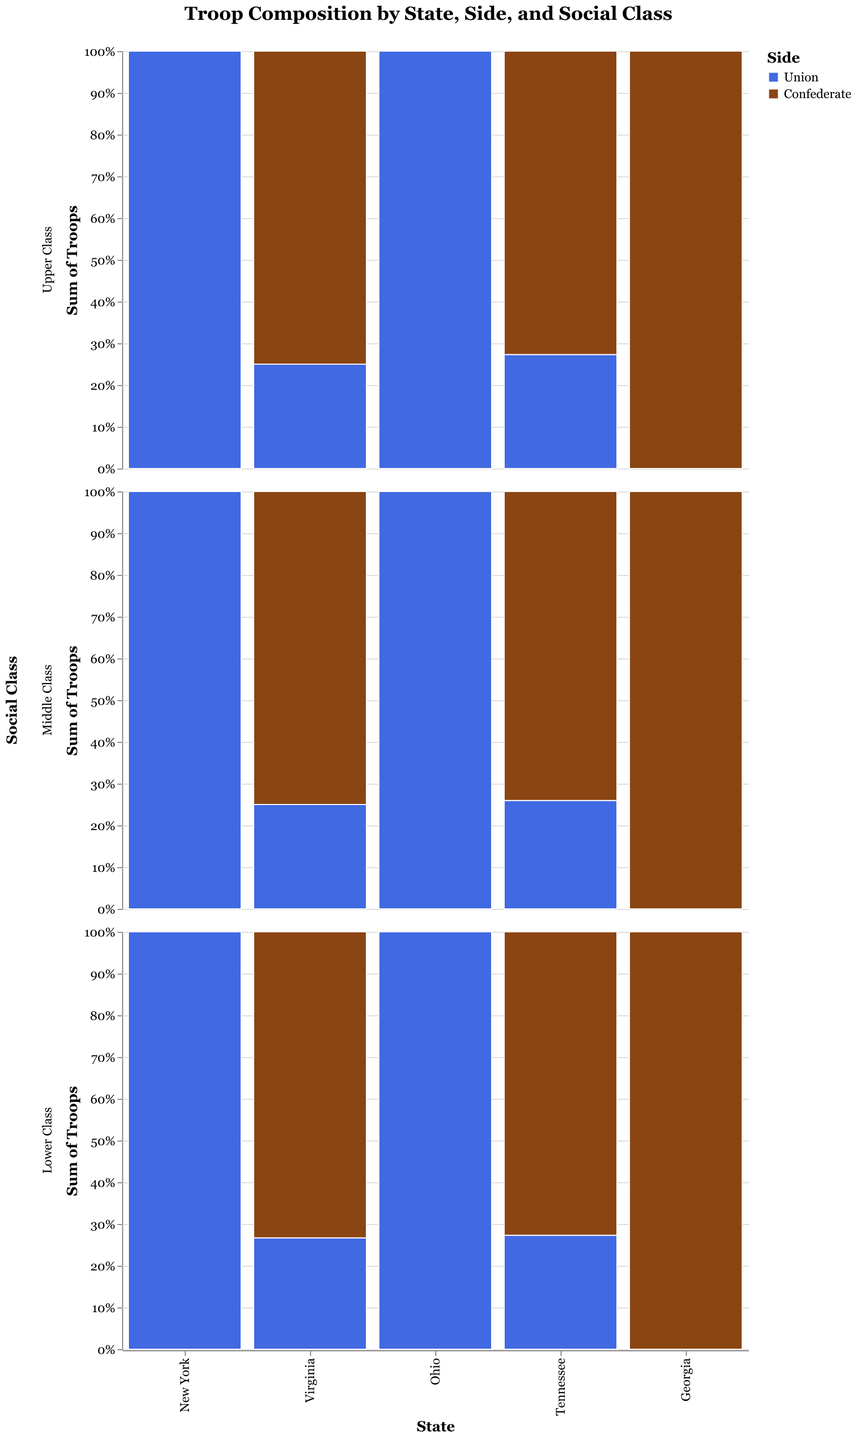What is the title of the figure? The title is located at the top center of the figure, and it generally provides a summary of what the chart is about.
Answer: Troop Composition by State, Side, and Social Class Which state contributes the most Union troops in the Lower Class? The figure has a section for Lower Class across each state and distinguishes between Union and Confederate troops by color. By looking at the total bar height and specifically at the Union section in blue, you can see which state has the most substantial amount.
Answer: New York Are there more Confederate or Union troops in Virginia? To determine this, observe the total height of bars for both sides in Virginia. Sum the heights for Confederate (brown) and Union (blue) bars.
Answer: Confederate Which side had more troops from the Upper Class in Georgia? Look at the Upper Class row for Georgia and compare the heights of the bars for Union (blue) and Confederate (brown).
Answer: Confederate What is the total number of lower-class Confederate troops in Tennessee and Georgia combined? Sum the values of lower-class Confederate troops from both Tennessee and Georgia. Tennessee has 40,000 and Georgia has 45,000. Adding these gives 85,000.
Answer: 85,000 Compare the number of middle-class Union troops in Ohio and Virginia. Which state contributed more? Look at the Middle Class row for both Ohio and Virginia. Compare the heights of the blue bars representing Union troops.
Answer: Ohio What proportion of middle-class troops in Virginia are Confederate? To determine the proportion, use the height of the Confederate middle-class section divided by the total height of the middle-class section (Confederate + Union) for Virginia, then multiply by 100 to get the percentage.
Answer: 75% In which state did the upper-class contribute more troops to the Union side compared to the Confederate side? Look at the Upper Class row across all states and compare the blue (Union) and brown (Confederate) sections. The state with a taller blue section than the brown section for Upper Class is New York and Ohio.
Answer: New York, Ohio How many total troops did the Union have in Ohio? Sum the number of Union upper-class, middle-class, and lower-class troops in Ohio. The totals are 15,000 (upper), 35,000 (middle), and 70,000 (lower). Adding these gives 120,000.
Answer: 120,000 Which social class contributed the least Confederate troops in Tennessee? Observe the bar heights within the Tennessee section for the Confederate side and identify the smallest bar among the Upper, Middle, and Lower classes.
Answer: Upper Class 